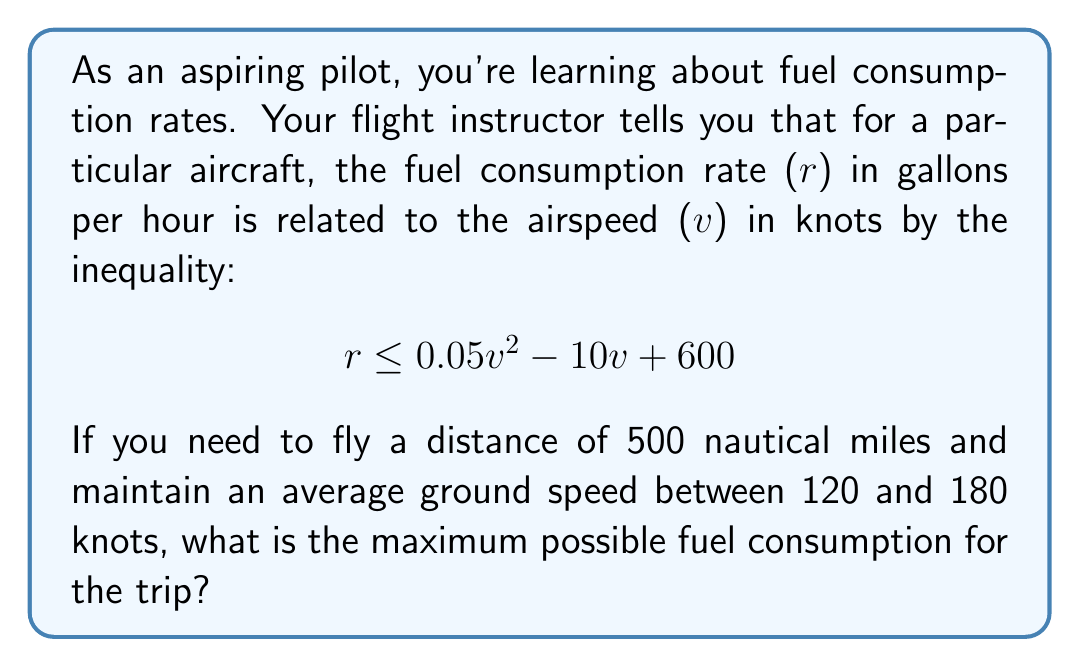Teach me how to tackle this problem. Let's approach this step-by-step:

1) First, we need to understand the relationship between time, distance, and speed:
   $$\text{Time} = \frac{\text{Distance}}{\text{Speed}}$$

2) We're given a distance of 500 nautical miles. The time will vary based on the speed chosen within the range 120-180 knots.

3) The fuel consumed will be the product of the fuel consumption rate and the time:
   $$\text{Fuel Consumed} = \text{Rate} \times \text{Time}$$

4) Substituting our distance/speed for time:
   $$\text{Fuel Consumed} = \text{Rate} \times \frac{500}{v}$$

5) We want to maximize this. The rate is bounded by the inequality:
   $$r \leq 0.05v^2 - 10v + 600$$

6) To maximize fuel consumption, we'll use the upper bound of this inequality for $r$:
   $$\text{Fuel Consumed} = (0.05v^2 - 10v + 600) \times \frac{500}{v}$$

7) Simplifying:
   $$\text{Fuel Consumed} = 25v - 5000 + \frac{300000}{v}$$

8) To find the maximum value of this function within our speed range, we can calculate its value at both ends of the range and at any critical points within the range.

9) At $v = 120$:
   $$25(120) - 5000 + \frac{300000}{120} = 5500$$

10) At $v = 180$:
    $$25(180) - 5000 + \frac{300000}{180} \approx 5166.67$$

11) The critical point (where the derivative equals zero) occurs at $v = 109.54$, which is outside our range.

12) Therefore, the maximum occurs at the lower speed limit, 120 knots.
Answer: The maximum possible fuel consumption for the trip is 5500 gallons. 